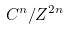Convert formula to latex. <formula><loc_0><loc_0><loc_500><loc_500>C ^ { n } / Z ^ { 2 n }</formula> 